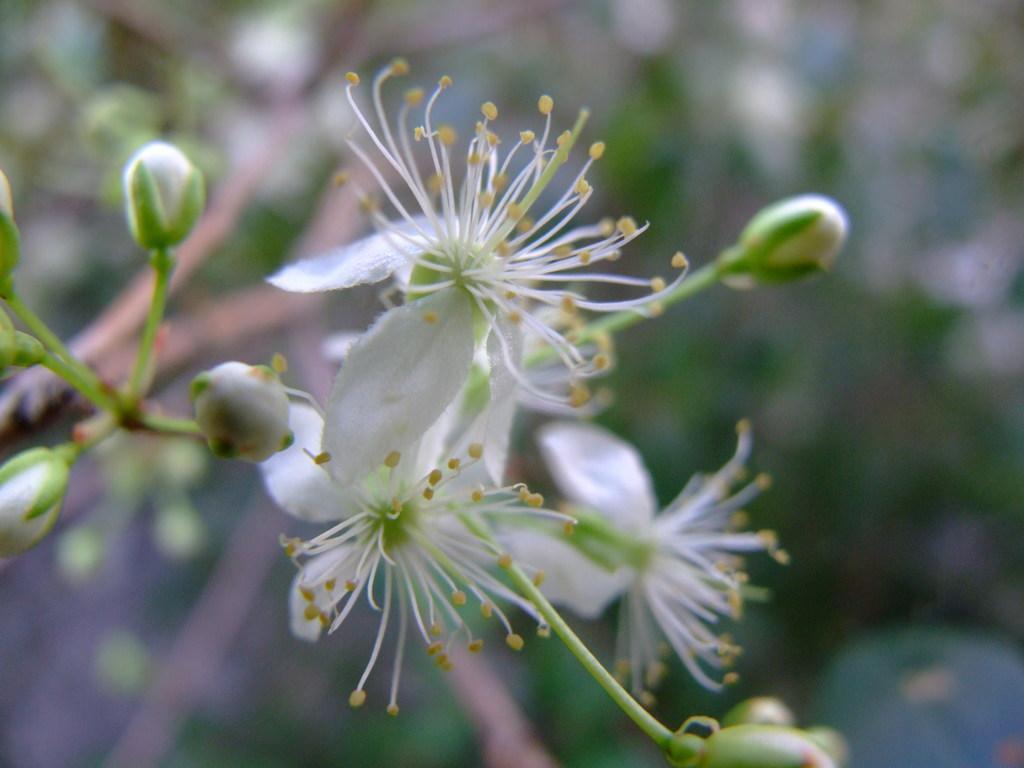Can you describe this image briefly? In this picture we can see few flowers, flower buds and blurry background. 